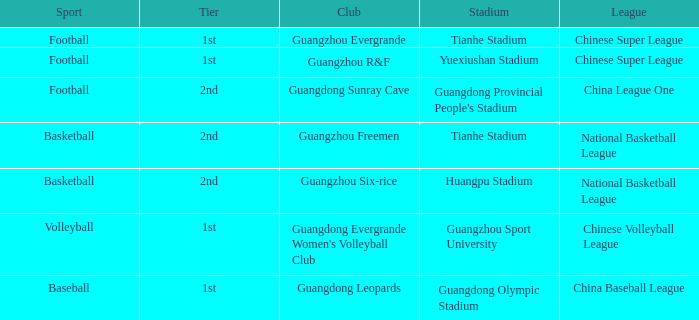Which stadium is for football with the China League One? Guangdong Provincial People's Stadium. 